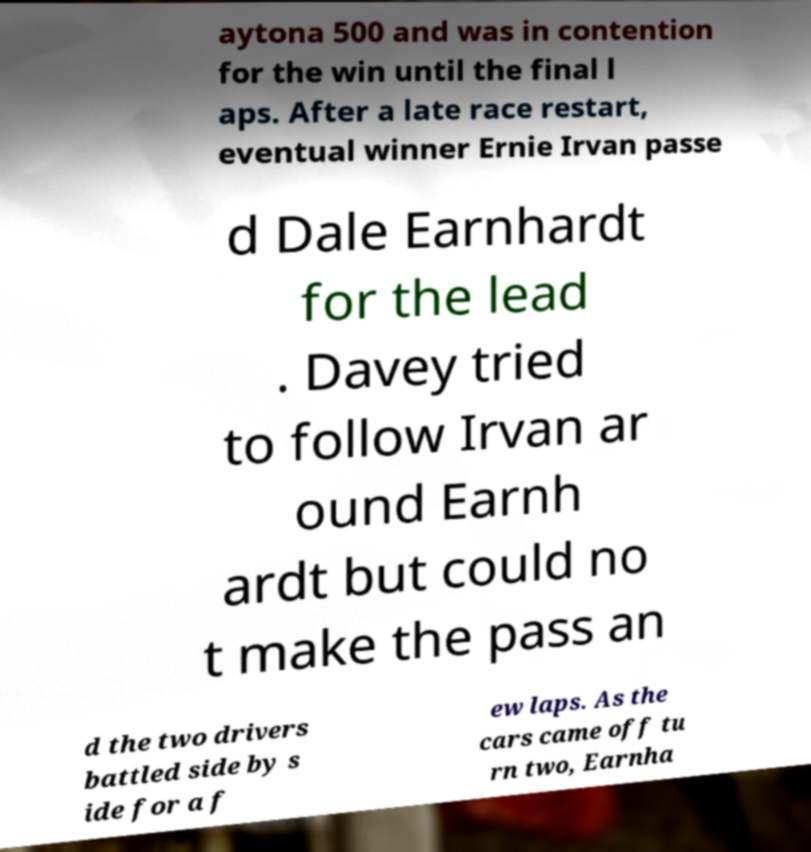Please read and relay the text visible in this image. What does it say? aytona 500 and was in contention for the win until the final l aps. After a late race restart, eventual winner Ernie Irvan passe d Dale Earnhardt for the lead . Davey tried to follow Irvan ar ound Earnh ardt but could no t make the pass an d the two drivers battled side by s ide for a f ew laps. As the cars came off tu rn two, Earnha 